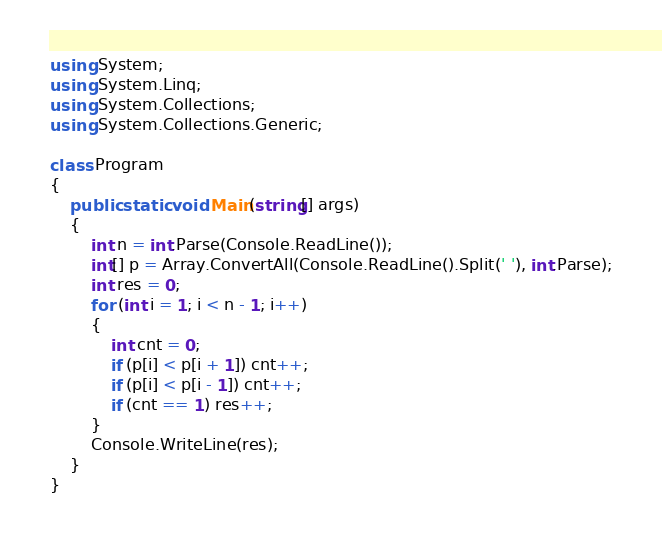Convert code to text. <code><loc_0><loc_0><loc_500><loc_500><_C#_>using System;
using System.Linq;
using System.Collections;
using System.Collections.Generic;

class Program
{
    public static void Main(string[] args)
    {
        int n = int.Parse(Console.ReadLine());
        int[] p = Array.ConvertAll(Console.ReadLine().Split(' '), int.Parse);
        int res = 0;
        for (int i = 1; i < n - 1; i++)
        {
            int cnt = 0;
            if (p[i] < p[i + 1]) cnt++;
            if (p[i] < p[i - 1]) cnt++;
            if (cnt == 1) res++;
        }
        Console.WriteLine(res);
    }
}</code> 